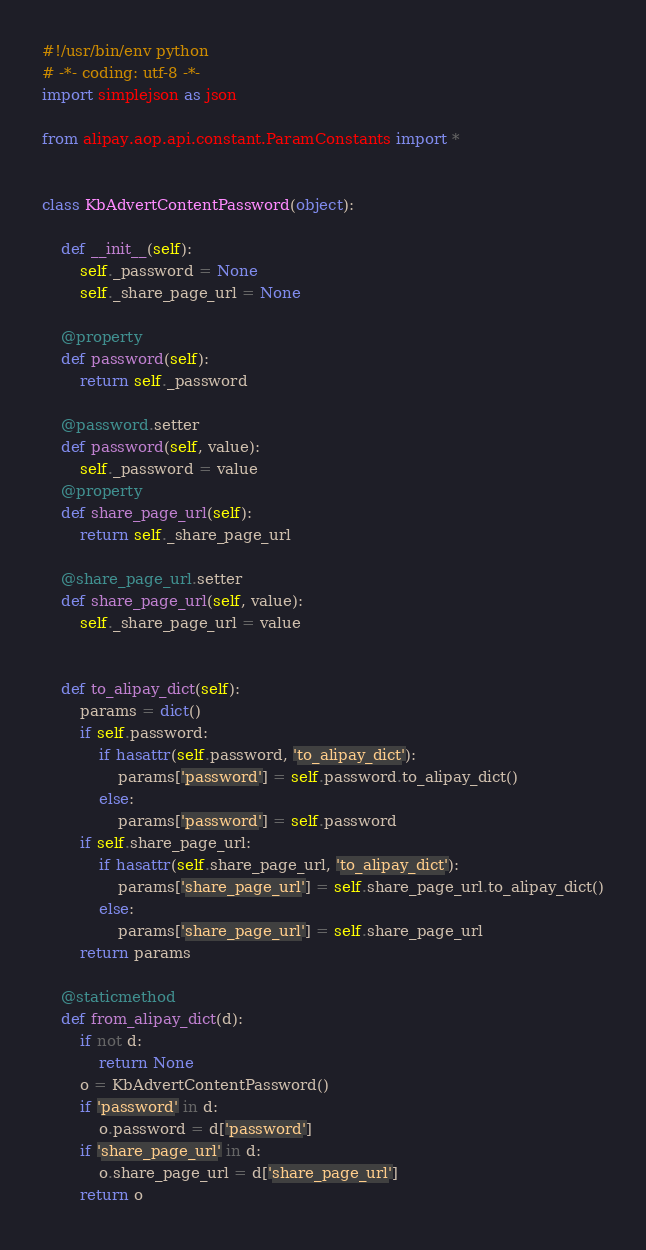Convert code to text. <code><loc_0><loc_0><loc_500><loc_500><_Python_>#!/usr/bin/env python
# -*- coding: utf-8 -*-
import simplejson as json

from alipay.aop.api.constant.ParamConstants import *


class KbAdvertContentPassword(object):

    def __init__(self):
        self._password = None
        self._share_page_url = None

    @property
    def password(self):
        return self._password

    @password.setter
    def password(self, value):
        self._password = value
    @property
    def share_page_url(self):
        return self._share_page_url

    @share_page_url.setter
    def share_page_url(self, value):
        self._share_page_url = value


    def to_alipay_dict(self):
        params = dict()
        if self.password:
            if hasattr(self.password, 'to_alipay_dict'):
                params['password'] = self.password.to_alipay_dict()
            else:
                params['password'] = self.password
        if self.share_page_url:
            if hasattr(self.share_page_url, 'to_alipay_dict'):
                params['share_page_url'] = self.share_page_url.to_alipay_dict()
            else:
                params['share_page_url'] = self.share_page_url
        return params

    @staticmethod
    def from_alipay_dict(d):
        if not d:
            return None
        o = KbAdvertContentPassword()
        if 'password' in d:
            o.password = d['password']
        if 'share_page_url' in d:
            o.share_page_url = d['share_page_url']
        return o


</code> 